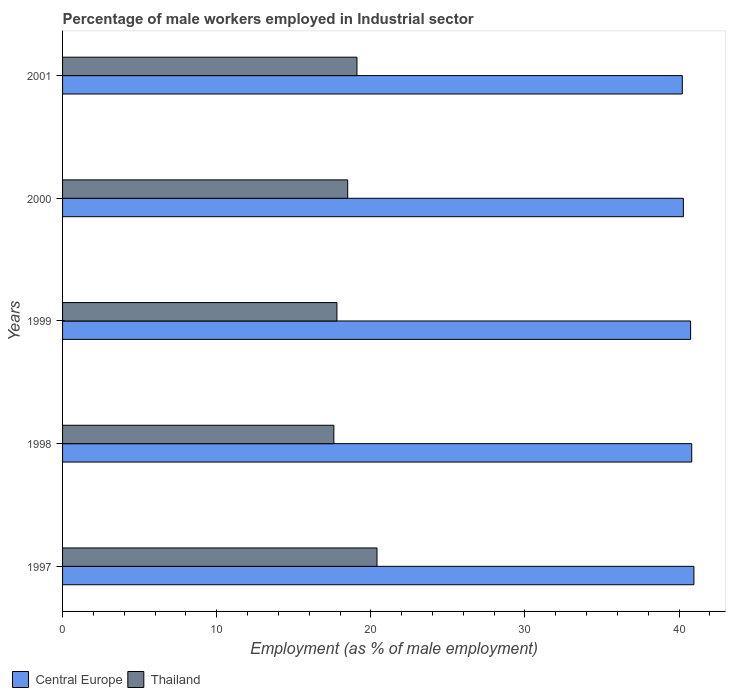Are the number of bars per tick equal to the number of legend labels?
Provide a short and direct response. Yes. How many bars are there on the 3rd tick from the top?
Offer a terse response. 2. What is the label of the 5th group of bars from the top?
Provide a succinct answer. 1997. What is the percentage of male workers employed in Industrial sector in Central Europe in 2001?
Provide a short and direct response. 40.21. Across all years, what is the maximum percentage of male workers employed in Industrial sector in Thailand?
Your answer should be very brief. 20.4. Across all years, what is the minimum percentage of male workers employed in Industrial sector in Thailand?
Offer a terse response. 17.6. In which year was the percentage of male workers employed in Industrial sector in Central Europe minimum?
Provide a succinct answer. 2001. What is the total percentage of male workers employed in Industrial sector in Central Europe in the graph?
Ensure brevity in your answer.  203.02. What is the difference between the percentage of male workers employed in Industrial sector in Thailand in 1998 and that in 1999?
Give a very brief answer. -0.2. What is the difference between the percentage of male workers employed in Industrial sector in Central Europe in 2000 and the percentage of male workers employed in Industrial sector in Thailand in 1998?
Provide a short and direct response. 22.68. What is the average percentage of male workers employed in Industrial sector in Central Europe per year?
Provide a succinct answer. 40.6. In the year 1997, what is the difference between the percentage of male workers employed in Industrial sector in Central Europe and percentage of male workers employed in Industrial sector in Thailand?
Your answer should be compact. 20.56. What is the ratio of the percentage of male workers employed in Industrial sector in Central Europe in 1999 to that in 2001?
Offer a very short reply. 1.01. What is the difference between the highest and the second highest percentage of male workers employed in Industrial sector in Thailand?
Ensure brevity in your answer.  1.3. What is the difference between the highest and the lowest percentage of male workers employed in Industrial sector in Thailand?
Keep it short and to the point. 2.8. In how many years, is the percentage of male workers employed in Industrial sector in Central Europe greater than the average percentage of male workers employed in Industrial sector in Central Europe taken over all years?
Your response must be concise. 3. Is the sum of the percentage of male workers employed in Industrial sector in Thailand in 1997 and 2000 greater than the maximum percentage of male workers employed in Industrial sector in Central Europe across all years?
Keep it short and to the point. No. What does the 1st bar from the top in 1999 represents?
Your answer should be very brief. Thailand. What does the 2nd bar from the bottom in 2001 represents?
Your response must be concise. Thailand. How many years are there in the graph?
Offer a terse response. 5. What is the difference between two consecutive major ticks on the X-axis?
Offer a very short reply. 10. Are the values on the major ticks of X-axis written in scientific E-notation?
Make the answer very short. No. Does the graph contain any zero values?
Make the answer very short. No. Does the graph contain grids?
Provide a succinct answer. No. Where does the legend appear in the graph?
Your answer should be very brief. Bottom left. How are the legend labels stacked?
Provide a short and direct response. Horizontal. What is the title of the graph?
Your response must be concise. Percentage of male workers employed in Industrial sector. Does "Georgia" appear as one of the legend labels in the graph?
Provide a succinct answer. No. What is the label or title of the X-axis?
Keep it short and to the point. Employment (as % of male employment). What is the Employment (as % of male employment) in Central Europe in 1997?
Give a very brief answer. 40.96. What is the Employment (as % of male employment) of Thailand in 1997?
Keep it short and to the point. 20.4. What is the Employment (as % of male employment) in Central Europe in 1998?
Your answer should be compact. 40.82. What is the Employment (as % of male employment) in Thailand in 1998?
Your response must be concise. 17.6. What is the Employment (as % of male employment) in Central Europe in 1999?
Provide a short and direct response. 40.75. What is the Employment (as % of male employment) of Thailand in 1999?
Your answer should be very brief. 17.8. What is the Employment (as % of male employment) of Central Europe in 2000?
Make the answer very short. 40.28. What is the Employment (as % of male employment) of Central Europe in 2001?
Keep it short and to the point. 40.21. What is the Employment (as % of male employment) in Thailand in 2001?
Your answer should be very brief. 19.1. Across all years, what is the maximum Employment (as % of male employment) in Central Europe?
Keep it short and to the point. 40.96. Across all years, what is the maximum Employment (as % of male employment) of Thailand?
Your answer should be compact. 20.4. Across all years, what is the minimum Employment (as % of male employment) of Central Europe?
Offer a terse response. 40.21. Across all years, what is the minimum Employment (as % of male employment) of Thailand?
Ensure brevity in your answer.  17.6. What is the total Employment (as % of male employment) in Central Europe in the graph?
Your answer should be very brief. 203.02. What is the total Employment (as % of male employment) of Thailand in the graph?
Offer a terse response. 93.4. What is the difference between the Employment (as % of male employment) in Central Europe in 1997 and that in 1998?
Give a very brief answer. 0.14. What is the difference between the Employment (as % of male employment) in Thailand in 1997 and that in 1998?
Ensure brevity in your answer.  2.8. What is the difference between the Employment (as % of male employment) of Central Europe in 1997 and that in 1999?
Your answer should be compact. 0.21. What is the difference between the Employment (as % of male employment) of Central Europe in 1997 and that in 2000?
Make the answer very short. 0.68. What is the difference between the Employment (as % of male employment) of Thailand in 1997 and that in 2000?
Offer a very short reply. 1.9. What is the difference between the Employment (as % of male employment) of Central Europe in 1997 and that in 2001?
Offer a terse response. 0.75. What is the difference between the Employment (as % of male employment) of Central Europe in 1998 and that in 1999?
Offer a terse response. 0.07. What is the difference between the Employment (as % of male employment) of Central Europe in 1998 and that in 2000?
Your response must be concise. 0.54. What is the difference between the Employment (as % of male employment) in Thailand in 1998 and that in 2000?
Ensure brevity in your answer.  -0.9. What is the difference between the Employment (as % of male employment) of Central Europe in 1998 and that in 2001?
Provide a succinct answer. 0.61. What is the difference between the Employment (as % of male employment) in Central Europe in 1999 and that in 2000?
Give a very brief answer. 0.47. What is the difference between the Employment (as % of male employment) of Thailand in 1999 and that in 2000?
Give a very brief answer. -0.7. What is the difference between the Employment (as % of male employment) of Central Europe in 1999 and that in 2001?
Make the answer very short. 0.54. What is the difference between the Employment (as % of male employment) in Central Europe in 2000 and that in 2001?
Provide a short and direct response. 0.07. What is the difference between the Employment (as % of male employment) of Central Europe in 1997 and the Employment (as % of male employment) of Thailand in 1998?
Offer a very short reply. 23.36. What is the difference between the Employment (as % of male employment) of Central Europe in 1997 and the Employment (as % of male employment) of Thailand in 1999?
Ensure brevity in your answer.  23.16. What is the difference between the Employment (as % of male employment) of Central Europe in 1997 and the Employment (as % of male employment) of Thailand in 2000?
Offer a terse response. 22.46. What is the difference between the Employment (as % of male employment) of Central Europe in 1997 and the Employment (as % of male employment) of Thailand in 2001?
Provide a succinct answer. 21.86. What is the difference between the Employment (as % of male employment) in Central Europe in 1998 and the Employment (as % of male employment) in Thailand in 1999?
Provide a short and direct response. 23.02. What is the difference between the Employment (as % of male employment) in Central Europe in 1998 and the Employment (as % of male employment) in Thailand in 2000?
Make the answer very short. 22.32. What is the difference between the Employment (as % of male employment) of Central Europe in 1998 and the Employment (as % of male employment) of Thailand in 2001?
Offer a very short reply. 21.72. What is the difference between the Employment (as % of male employment) of Central Europe in 1999 and the Employment (as % of male employment) of Thailand in 2000?
Offer a terse response. 22.25. What is the difference between the Employment (as % of male employment) in Central Europe in 1999 and the Employment (as % of male employment) in Thailand in 2001?
Keep it short and to the point. 21.65. What is the difference between the Employment (as % of male employment) in Central Europe in 2000 and the Employment (as % of male employment) in Thailand in 2001?
Provide a short and direct response. 21.18. What is the average Employment (as % of male employment) of Central Europe per year?
Offer a terse response. 40.6. What is the average Employment (as % of male employment) of Thailand per year?
Ensure brevity in your answer.  18.68. In the year 1997, what is the difference between the Employment (as % of male employment) in Central Europe and Employment (as % of male employment) in Thailand?
Offer a very short reply. 20.56. In the year 1998, what is the difference between the Employment (as % of male employment) of Central Europe and Employment (as % of male employment) of Thailand?
Your answer should be very brief. 23.22. In the year 1999, what is the difference between the Employment (as % of male employment) in Central Europe and Employment (as % of male employment) in Thailand?
Provide a succinct answer. 22.95. In the year 2000, what is the difference between the Employment (as % of male employment) in Central Europe and Employment (as % of male employment) in Thailand?
Your response must be concise. 21.78. In the year 2001, what is the difference between the Employment (as % of male employment) in Central Europe and Employment (as % of male employment) in Thailand?
Offer a very short reply. 21.11. What is the ratio of the Employment (as % of male employment) in Thailand in 1997 to that in 1998?
Ensure brevity in your answer.  1.16. What is the ratio of the Employment (as % of male employment) of Thailand in 1997 to that in 1999?
Provide a succinct answer. 1.15. What is the ratio of the Employment (as % of male employment) of Central Europe in 1997 to that in 2000?
Your answer should be very brief. 1.02. What is the ratio of the Employment (as % of male employment) in Thailand in 1997 to that in 2000?
Offer a very short reply. 1.1. What is the ratio of the Employment (as % of male employment) of Central Europe in 1997 to that in 2001?
Keep it short and to the point. 1.02. What is the ratio of the Employment (as % of male employment) in Thailand in 1997 to that in 2001?
Make the answer very short. 1.07. What is the ratio of the Employment (as % of male employment) in Thailand in 1998 to that in 1999?
Ensure brevity in your answer.  0.99. What is the ratio of the Employment (as % of male employment) of Central Europe in 1998 to that in 2000?
Offer a very short reply. 1.01. What is the ratio of the Employment (as % of male employment) in Thailand in 1998 to that in 2000?
Keep it short and to the point. 0.95. What is the ratio of the Employment (as % of male employment) in Central Europe in 1998 to that in 2001?
Give a very brief answer. 1.02. What is the ratio of the Employment (as % of male employment) of Thailand in 1998 to that in 2001?
Make the answer very short. 0.92. What is the ratio of the Employment (as % of male employment) of Central Europe in 1999 to that in 2000?
Make the answer very short. 1.01. What is the ratio of the Employment (as % of male employment) of Thailand in 1999 to that in 2000?
Keep it short and to the point. 0.96. What is the ratio of the Employment (as % of male employment) of Central Europe in 1999 to that in 2001?
Provide a succinct answer. 1.01. What is the ratio of the Employment (as % of male employment) of Thailand in 1999 to that in 2001?
Keep it short and to the point. 0.93. What is the ratio of the Employment (as % of male employment) of Central Europe in 2000 to that in 2001?
Provide a succinct answer. 1. What is the ratio of the Employment (as % of male employment) in Thailand in 2000 to that in 2001?
Your answer should be compact. 0.97. What is the difference between the highest and the second highest Employment (as % of male employment) of Central Europe?
Keep it short and to the point. 0.14. What is the difference between the highest and the lowest Employment (as % of male employment) of Central Europe?
Your response must be concise. 0.75. 